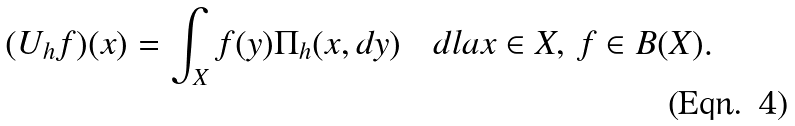Convert formula to latex. <formula><loc_0><loc_0><loc_500><loc_500>( U _ { h } f ) ( x ) = \int _ { X } f ( y ) \Pi _ { h } ( x , d y ) \quad d l a x \in X , \, f \in B ( X ) .</formula> 